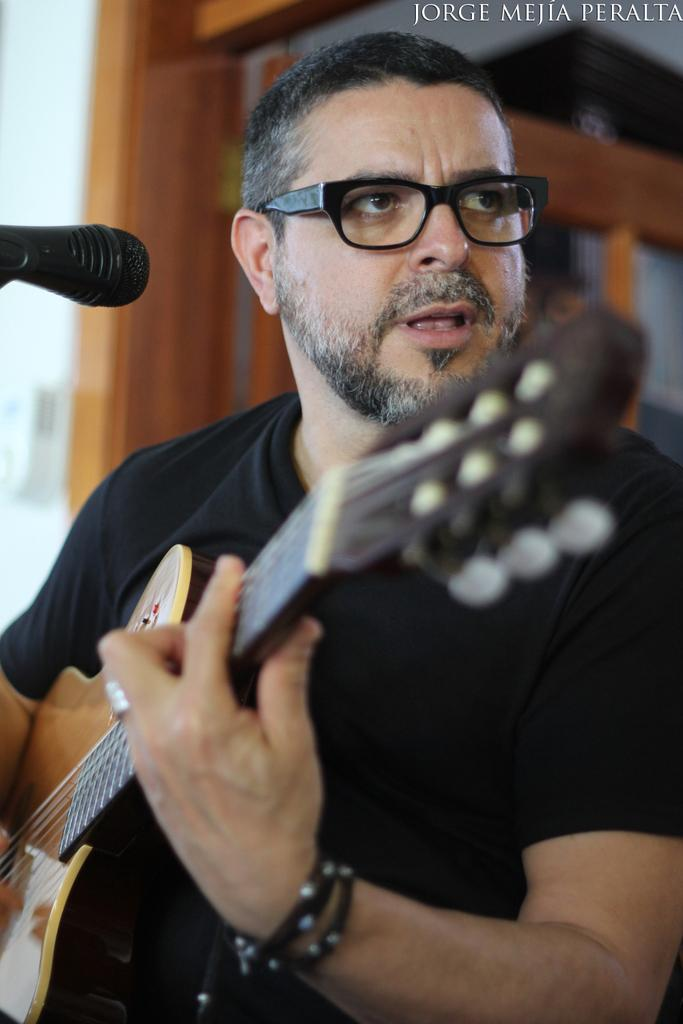What is the man in the image holding? The man is holding a guitar. What object is present in the image that is typically used for amplifying sound? There is a microphone (mic) in the image. What type of shade can be seen in the image? There is no shade present in the image; it only shows a man holding a guitar and a microphone. 